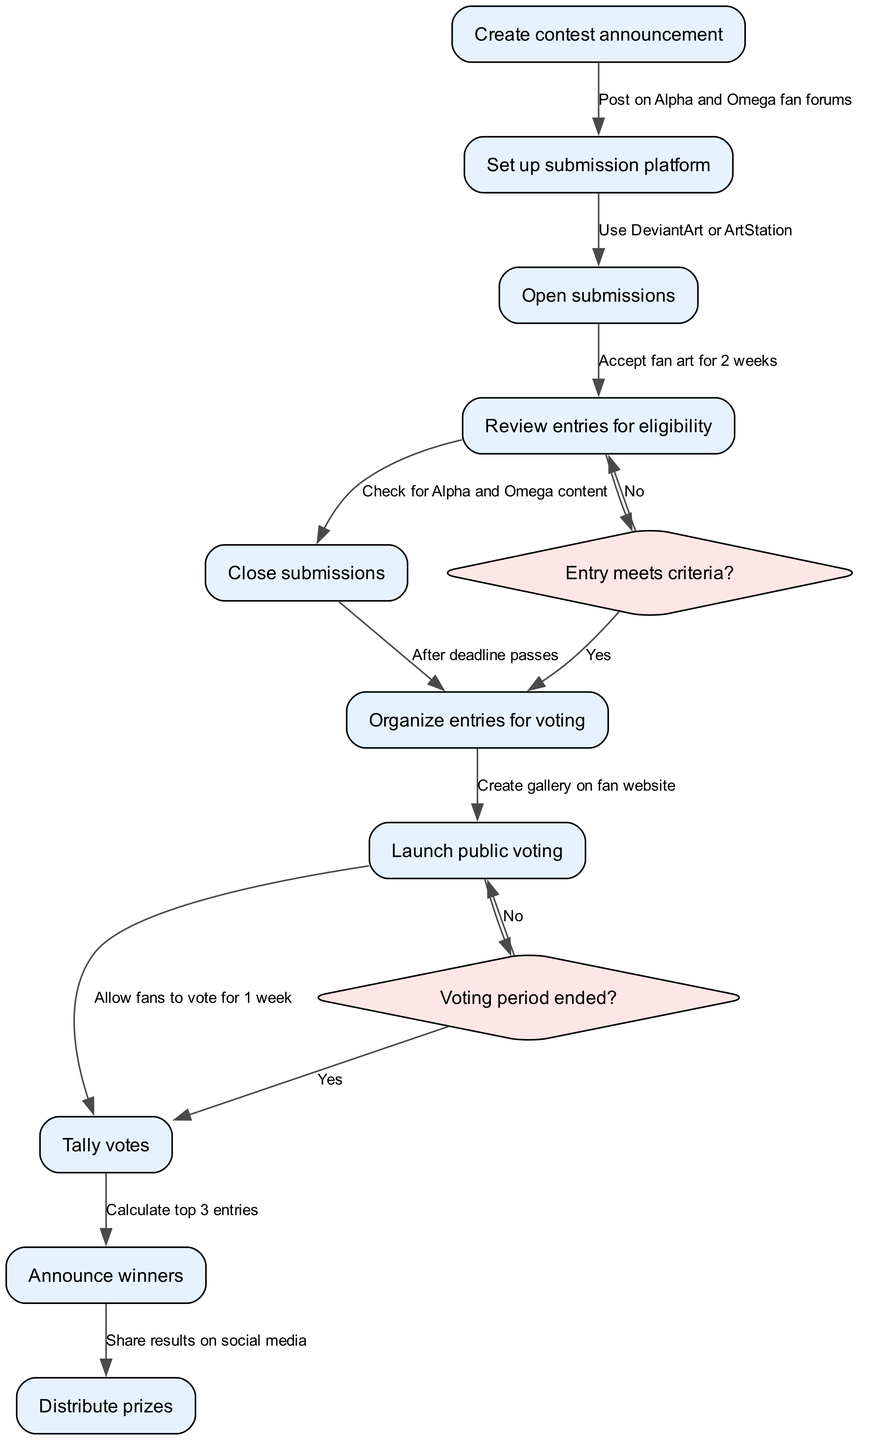What is the first step in the contest process? The first node in the diagram is "Create contest announcement," which marks the starting point of the contest process.
Answer: Create contest announcement How many nodes are in the diagram? By counting each unique action in the nodes section of the diagram, we find there are 10 nodes representing various steps in the contest.
Answer: 10 What action follows "Open submissions"? Moving from the "Open submissions" node, the next action is "Review entries for eligibility," showing the sequential flow of the contest.
Answer: Review entries for eligibility What happens if an entry does not meet the criteria? According to the decision node "Entry meets criteria?", if the answer is "No," the flow directs back to "Review entries for eligibility," indicating further checks are needed.
Answer: Review entries for eligibility What is the total number of edges in the diagram? The edges connecting the nodes are counted, resulting in a total of 9 edges showing the relationships and transitions between different steps in the contest process.
Answer: 9 What is the last action in the contest process? The final step in the process, represented in the last node of the diagram, is "Distribute prizes," which is the concluding action after winners are announced.
Answer: Distribute prizes How long is the voting period? According to the node labeled "Allow fans to vote for 1 week," the voting period is explicitly defined as one week.
Answer: 1 week After the voting period ends, what happens next? The subsequent action is determined by the decision node "Voting period ended?", which leads to "Tally votes" if the answer is "Yes." This illustrates the step taken after voting concludes.
Answer: Tally votes What happens to entries that meet the eligibility criteria? For entries that pass the eligibility check, the flow moves forward from "Review entries for eligibility" to "Organize entries for voting," indicating their approval for the next stage.
Answer: Organize entries for voting 